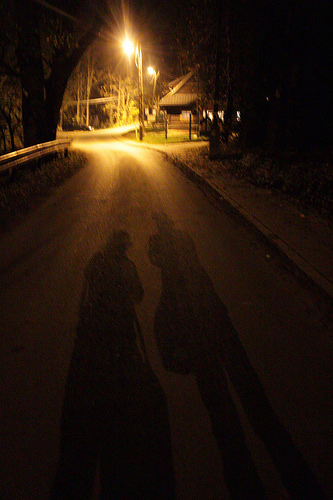<image>
Is there a shadow under the house? No. The shadow is not positioned under the house. The vertical relationship between these objects is different. 